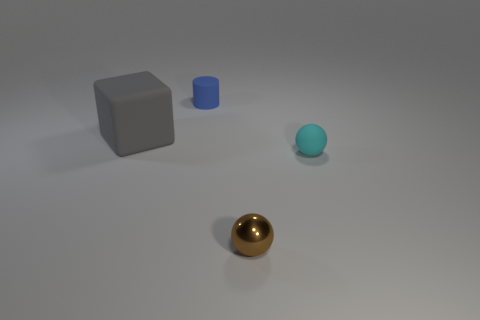Add 3 tiny green matte objects. How many objects exist? 7 Subtract all cubes. How many objects are left? 3 Add 2 blue matte things. How many blue matte things exist? 3 Subtract 1 gray cubes. How many objects are left? 3 Subtract all large gray blocks. Subtract all tiny brown shiny spheres. How many objects are left? 2 Add 1 tiny brown things. How many tiny brown things are left? 2 